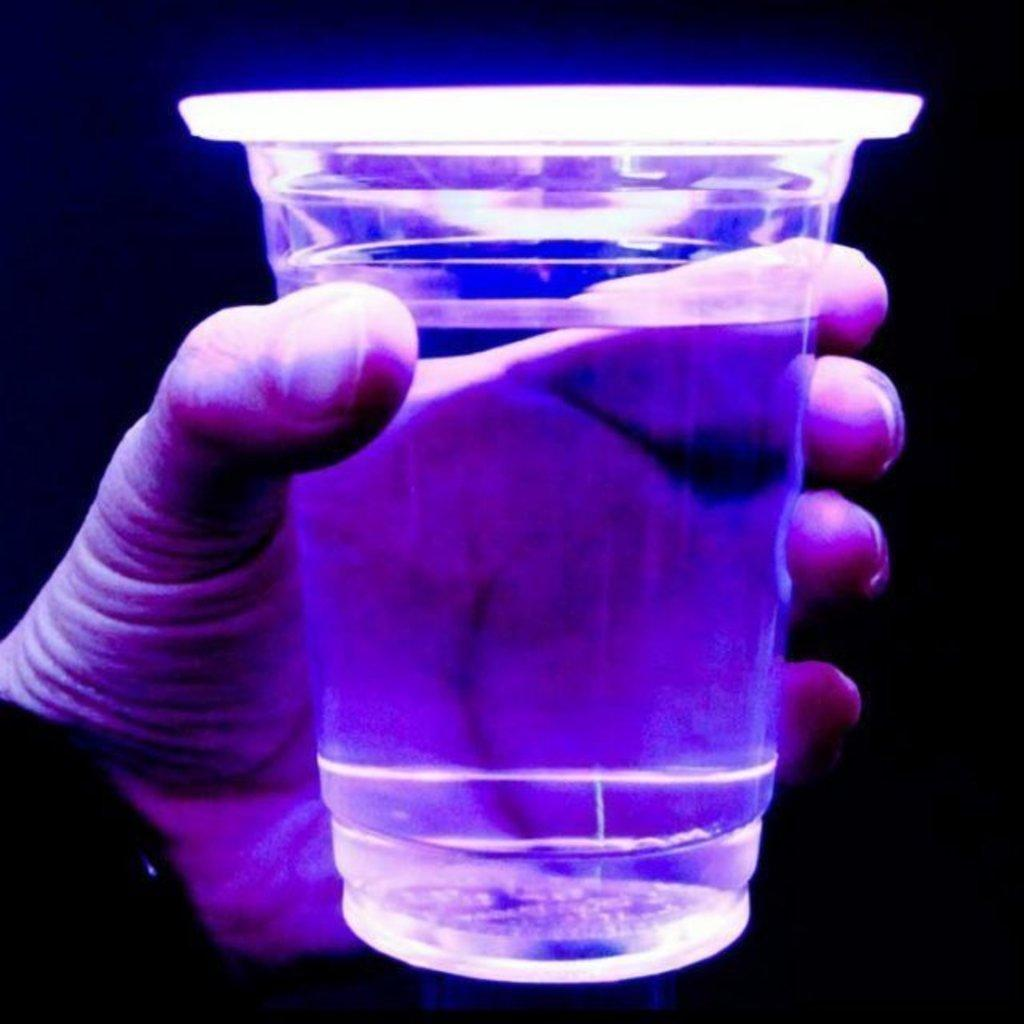What can be seen in the image related to a person's hand? There is a person's hand in the image. What is the hand holding? The hand is holding a glass. What is inside the glass? The glass contains a liquid. What can be observed about the background of the image? The background of the image is dark. What type of crack can be seen on the stem of the glass in the image? There is no stem on the glass in the image, as it is a regular glass without any stem. 